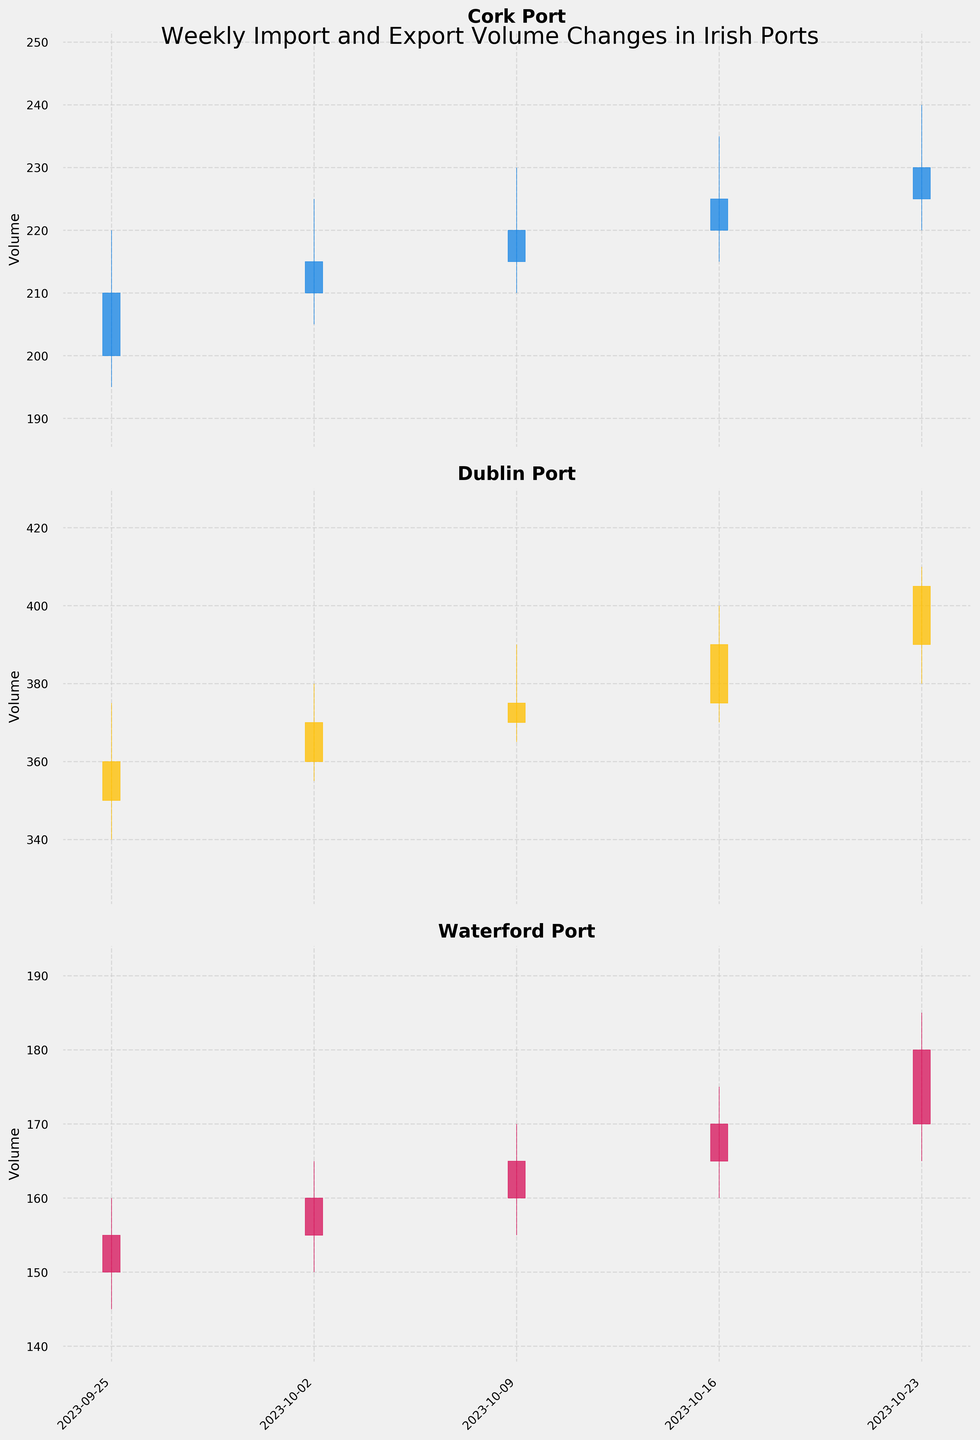what is the title of the figure? The title is written at the top of the figure and summarizes the main topic of the plot. In this case, it mentions "Weekly Import and Export Volume Changes in Irish Ports."
Answer: Weekly Import and Export Volume Changes in Irish Ports How many ports are analyzed in the figure? The figure has three subplots, each labeled with the name of a port. These subplots represent Dublin Port, Cork Port, and Waterford Port.
Answer: 3 What is the color used for an upward movement in Cork Port? The color indicating an upward movement in Cork Port is represented by a distinct color. For Cork Port, this color is yellow, which is used for the candlesticks that have a closing price higher than the opening price.
Answer: Yellow Which port shows the highest closing volume on 2023-10-23? To find the highest closing volume on 2023-10-23, look at the closing prices for each port on that date. For Dublin Port, it's 405; for Cork Port, it's 230; and for Waterford Port, it's 180. Thus, Dublin Port has the highest closing volume.
Answer: Dublin Port Between which two weeks did Dublin Port see the largest increase in closing volume? By analyzing the closing prices for Dublin Port on different dates, we observe: 2023-09-25 (360), 2023-10-02 (370), 2023-10-09 (375), 2023-10-16 (390), and 2023-10-23 (405). The largest increase in closing volume is between 2023-10-16 (390) and 2023-10-23 (405), which is an increase of 15 units.
Answer: Between 2023-10-16 and 2023-10-23 What is the average closing volume for Waterford Port over the five weeks? To find the average closing volume, add the closing volumes for Waterford Port over the five weeks and divide by 5: (155 + 160 + 165 + 170 + 180) / 5 = 830 / 5 = 166.
Answer: 166 Did Cork Port ever experience a decrease in its closing volume between consecutive weeks? We need to observe the closing volumes for Cork Port over the weeks: 2023-09-25 (210), 2023-10-02 (215), 2023-10-09 (220), 2023-10-16 (225), 2023-10-23 (230). Since the closing volumes are consistently increasing, Cork Port did not experience a decrease between consecutive weeks.
Answer: No Which port has the most stable closing volume trend? To assess the stability, observe the consistency of the closing volumes over the weeks: Dublin Port (360, 370, 375, 390, 405), Cork Port (210, 215, 220, 225, 230), and Waterford Port (155, 160, 165, 170, 180). Cork Port shows the most stable trend with consistent, minimal increases.
Answer: Cork Port What was the lowest trading volume for Waterford Port in the period shown? The lowest trading volume for Waterford Port, as indicated by the lowest value among the "Low" column for various weeks, is 145 on 2023-09-25.
Answer: 145 